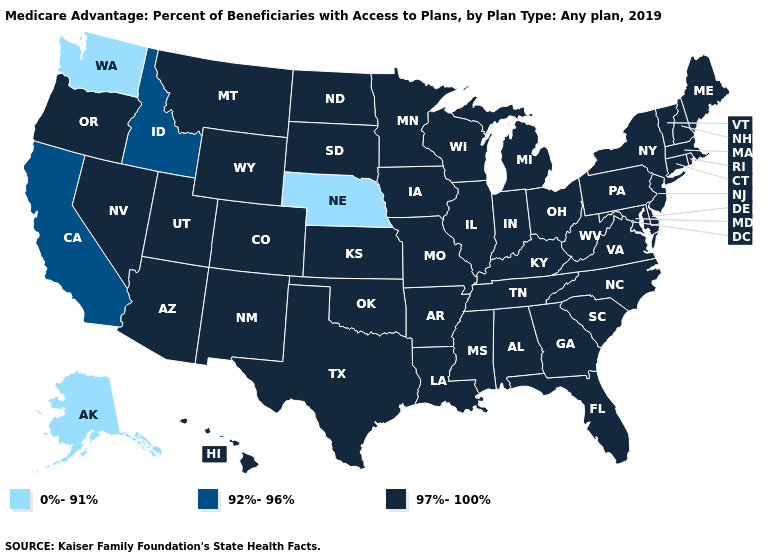Which states have the lowest value in the USA?
Quick response, please. Alaska, Nebraska, Washington. What is the value of West Virginia?
Answer briefly. 97%-100%. What is the value of Nevada?
Short answer required. 97%-100%. Name the states that have a value in the range 0%-91%?
Answer briefly. Alaska, Nebraska, Washington. Does the first symbol in the legend represent the smallest category?
Short answer required. Yes. Which states have the lowest value in the USA?
Keep it brief. Alaska, Nebraska, Washington. Name the states that have a value in the range 0%-91%?
Answer briefly. Alaska, Nebraska, Washington. What is the lowest value in the MidWest?
Short answer required. 0%-91%. What is the value of New Jersey?
Short answer required. 97%-100%. Does the first symbol in the legend represent the smallest category?
Answer briefly. Yes. Name the states that have a value in the range 97%-100%?
Short answer required. Alabama, Arizona, Arkansas, Colorado, Connecticut, Delaware, Florida, Georgia, Hawaii, Illinois, Indiana, Iowa, Kansas, Kentucky, Louisiana, Maine, Maryland, Massachusetts, Michigan, Minnesota, Mississippi, Missouri, Montana, Nevada, New Hampshire, New Jersey, New Mexico, New York, North Carolina, North Dakota, Ohio, Oklahoma, Oregon, Pennsylvania, Rhode Island, South Carolina, South Dakota, Tennessee, Texas, Utah, Vermont, Virginia, West Virginia, Wisconsin, Wyoming. What is the highest value in the USA?
Concise answer only. 97%-100%. What is the value of Kentucky?
Be succinct. 97%-100%. Name the states that have a value in the range 0%-91%?
Answer briefly. Alaska, Nebraska, Washington. 